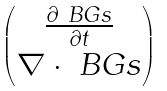<formula> <loc_0><loc_0><loc_500><loc_500>\begin{pmatrix} \frac { \partial \ B G s } { \partial t } \\ \nabla \cdot \ B G s \end{pmatrix}</formula> 